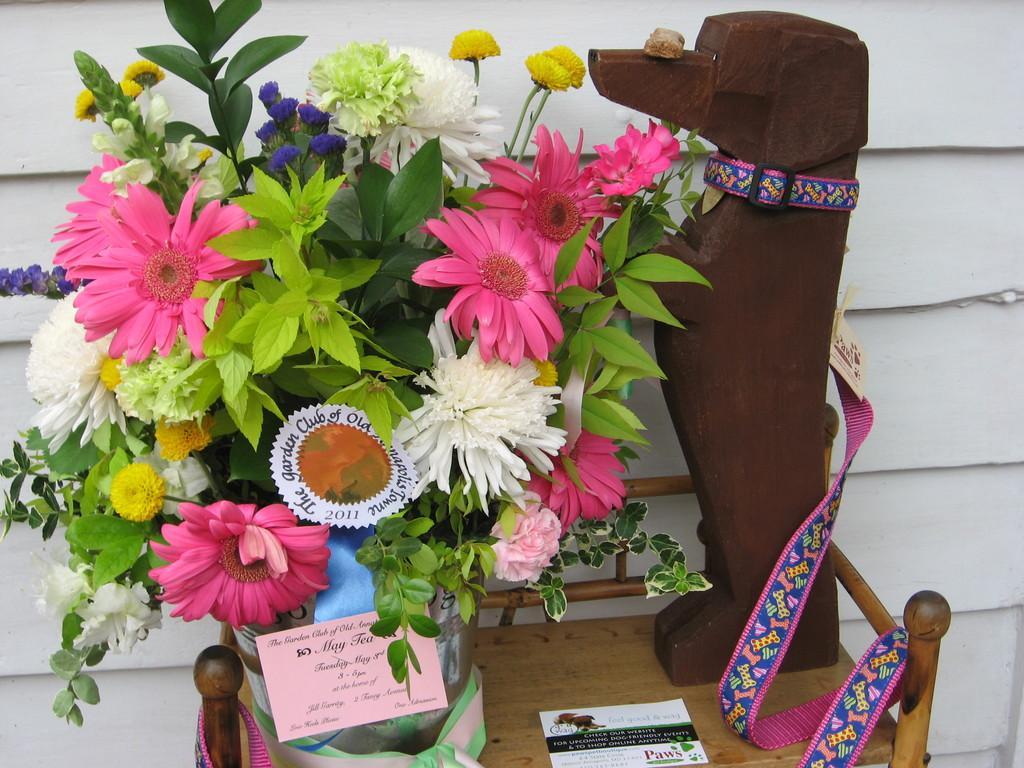Could you give a brief overview of what you see in this image? In this image there are a few flowers placed on a table, beside the flowers there is a dog's structure made from wood. 